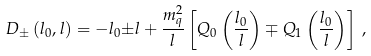<formula> <loc_0><loc_0><loc_500><loc_500>D _ { \pm } \left ( l _ { 0 } , l \right ) = - l _ { 0 } { \pm } l + \frac { m _ { q } ^ { 2 } } { l } \left [ Q _ { 0 } \left ( \frac { l _ { 0 } } { l } \right ) \mp Q _ { 1 } \left ( \frac { l _ { 0 } } { l } \right ) \right ] \, ,</formula> 